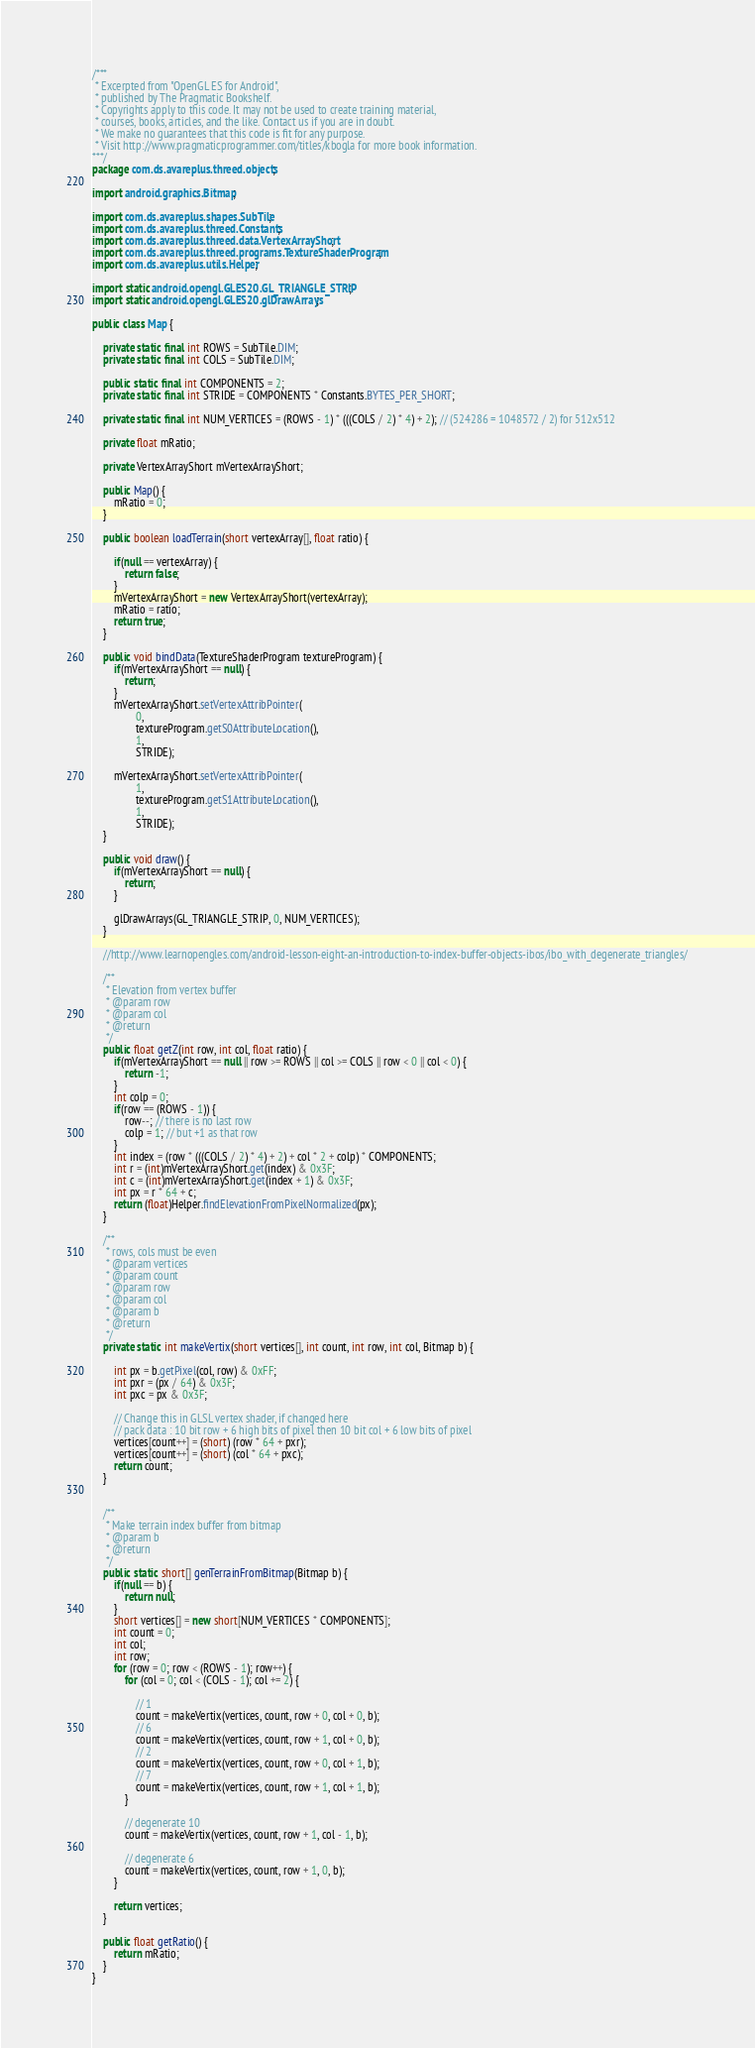Convert code to text. <code><loc_0><loc_0><loc_500><loc_500><_Java_>/***
 * Excerpted from "OpenGL ES for Android",
 * published by The Pragmatic Bookshelf.
 * Copyrights apply to this code. It may not be used to create training material, 
 * courses, books, articles, and the like. Contact us if you are in doubt.
 * We make no guarantees that this code is fit for any purpose. 
 * Visit http://www.pragmaticprogrammer.com/titles/kbogla for more book information.
***/
package com.ds.avareplus.threed.objects;

import android.graphics.Bitmap;

import com.ds.avareplus.shapes.SubTile;
import com.ds.avareplus.threed.Constants;
import com.ds.avareplus.threed.data.VertexArrayShort;
import com.ds.avareplus.threed.programs.TextureShaderProgram;
import com.ds.avareplus.utils.Helper;

import static android.opengl.GLES20.GL_TRIANGLE_STRIP;
import static android.opengl.GLES20.glDrawArrays;

public class Map {

    private static final int ROWS = SubTile.DIM;
    private static final int COLS = SubTile.DIM;

    public static final int COMPONENTS = 2;
    private static final int STRIDE = COMPONENTS * Constants.BYTES_PER_SHORT;

    private static final int NUM_VERTICES = (ROWS - 1) * (((COLS / 2) * 4) + 2); // (524286 = 1048572 / 2) for 512x512

    private float mRatio;

    private VertexArrayShort mVertexArrayShort;

    public Map() {
        mRatio = 0;
    }

    public boolean loadTerrain(short vertexArray[], float ratio) {

        if(null == vertexArray) {
            return false;
        }
        mVertexArrayShort = new VertexArrayShort(vertexArray);
        mRatio = ratio;
        return true;
    }

    public void bindData(TextureShaderProgram textureProgram) {
        if(mVertexArrayShort == null) {
            return;
        }
        mVertexArrayShort.setVertexAttribPointer(
                0,
                textureProgram.getS0AttributeLocation(),
                1,
                STRIDE);
        
        mVertexArrayShort.setVertexAttribPointer(
                1,
                textureProgram.getS1AttributeLocation(),
                1,
                STRIDE);
    }
    
    public void draw() {
        if(mVertexArrayShort == null) {
            return;
        }

        glDrawArrays(GL_TRIANGLE_STRIP, 0, NUM_VERTICES);
    }

    //http://www.learnopengles.com/android-lesson-eight-an-introduction-to-index-buffer-objects-ibos/ibo_with_degenerate_triangles/

    /**
     * Elevation from vertex buffer
     * @param row
     * @param col
     * @return
     */
    public float getZ(int row, int col, float ratio) {
        if(mVertexArrayShort == null || row >= ROWS || col >= COLS || row < 0 || col < 0) {
            return -1;
        }
        int colp = 0;
        if(row == (ROWS - 1)) {
            row--; // there is no last row
            colp = 1; // but +1 as that row
        }
        int index = (row * (((COLS / 2) * 4) + 2) + col * 2 + colp) * COMPONENTS;
        int r = (int)mVertexArrayShort.get(index) & 0x3F;
        int c = (int)mVertexArrayShort.get(index + 1) & 0x3F;
        int px = r * 64 + c;
        return (float)Helper.findElevationFromPixelNormalized(px);
    }

    /**
     * rows, cols must be even
     * @param vertices
     * @param count
     * @param row
     * @param col
     * @param b
     * @return
     */
    private static int makeVertix(short vertices[], int count, int row, int col, Bitmap b) {

        int px = b.getPixel(col, row) & 0xFF;
        int pxr = (px / 64) & 0x3F;
        int pxc = px & 0x3F;

        // Change this in GLSL vertex shader, if changed here
        // pack data : 10 bit row + 6 high bits of pixel then 10 bit col + 6 low bits of pixel
        vertices[count++] = (short) (row * 64 + pxr);
        vertices[count++] = (short) (col * 64 + pxc);
        return count;
    }


    /**
     * Make terrain index buffer from bitmap
     * @param b
     * @return
     */
    public static short[] genTerrainFromBitmap(Bitmap b) {
        if(null == b) {
            return null;
        }
        short vertices[] = new short[NUM_VERTICES * COMPONENTS];
        int count = 0;
        int col;
        int row;
        for (row = 0; row < (ROWS - 1); row++) {
            for (col = 0; col < (COLS - 1); col += 2) {

                // 1
                count = makeVertix(vertices, count, row + 0, col + 0, b);
                // 6
                count = makeVertix(vertices, count, row + 1, col + 0, b);
                // 2
                count = makeVertix(vertices, count, row + 0, col + 1, b);
                // 7
                count = makeVertix(vertices, count, row + 1, col + 1, b);
            }

            // degenerate 10
            count = makeVertix(vertices, count, row + 1, col - 1, b);

            // degenerate 6
            count = makeVertix(vertices, count, row + 1, 0, b);
        }

        return vertices;
    }

    public float getRatio() {
        return mRatio;
    }
}
</code> 